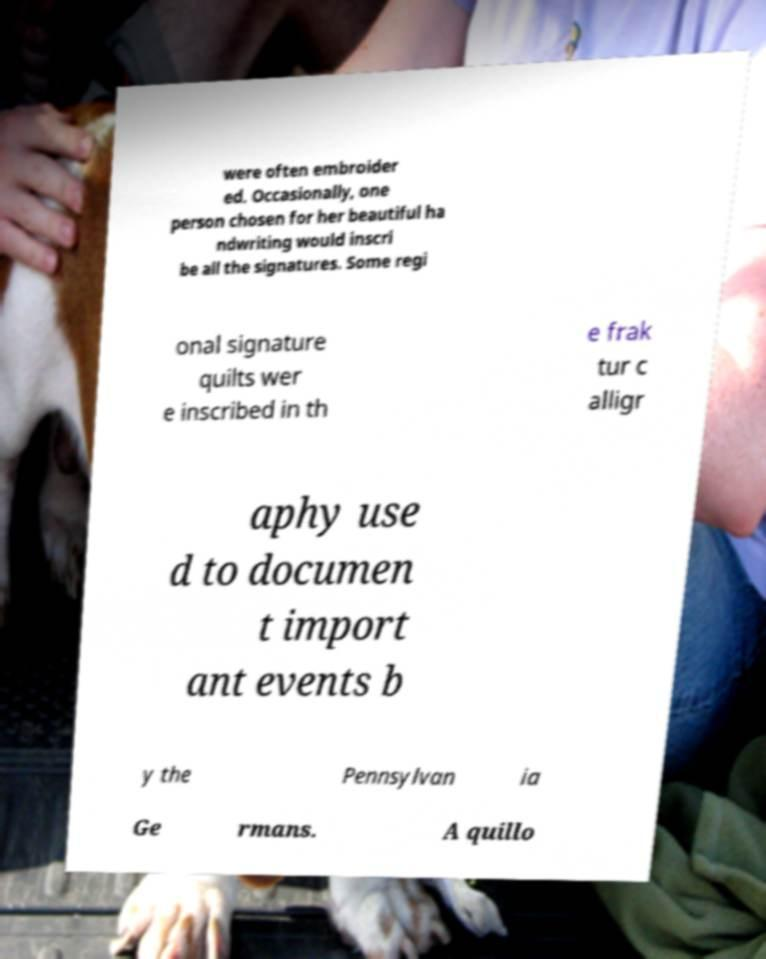Could you assist in decoding the text presented in this image and type it out clearly? were often embroider ed. Occasionally, one person chosen for her beautiful ha ndwriting would inscri be all the signatures. Some regi onal signature quilts wer e inscribed in th e frak tur c alligr aphy use d to documen t import ant events b y the Pennsylvan ia Ge rmans. A quillo 